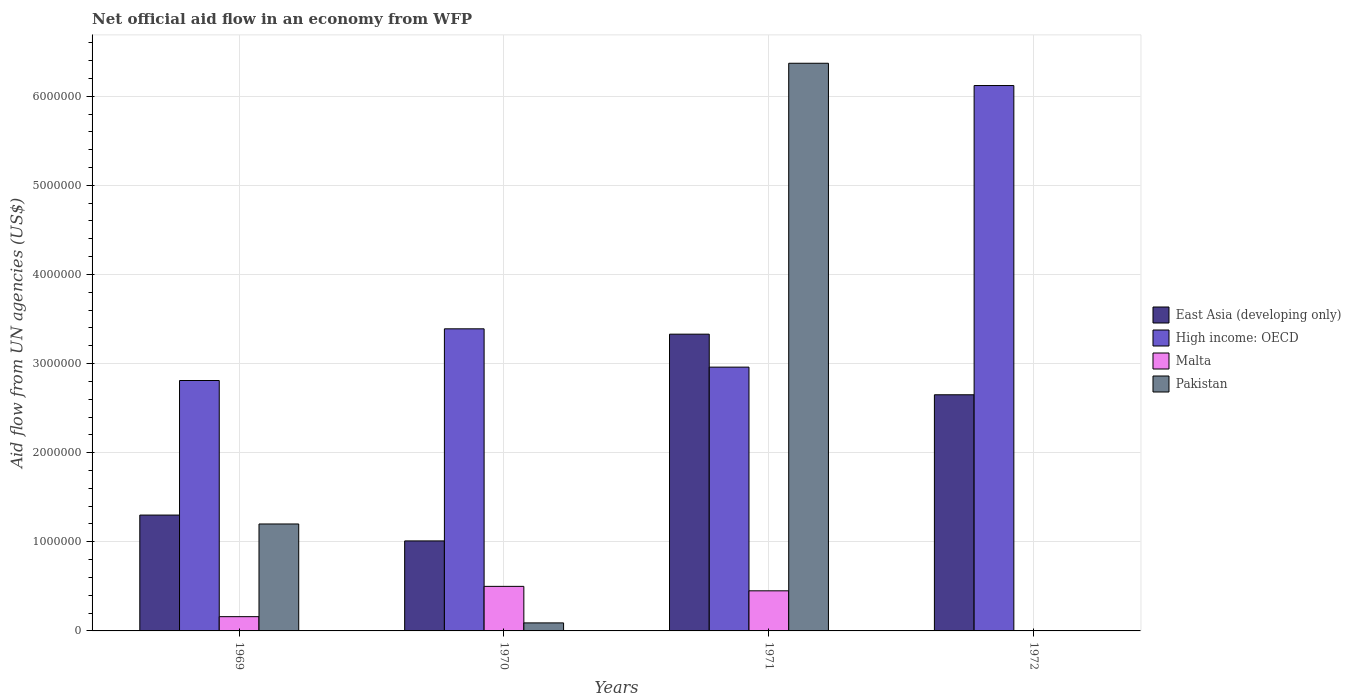How many groups of bars are there?
Provide a short and direct response. 4. Are the number of bars per tick equal to the number of legend labels?
Your answer should be very brief. No. How many bars are there on the 3rd tick from the right?
Provide a succinct answer. 4. What is the label of the 3rd group of bars from the left?
Give a very brief answer. 1971. What is the net official aid flow in Pakistan in 1971?
Offer a terse response. 6.37e+06. Across all years, what is the maximum net official aid flow in High income: OECD?
Ensure brevity in your answer.  6.12e+06. In which year was the net official aid flow in High income: OECD maximum?
Ensure brevity in your answer.  1972. What is the total net official aid flow in High income: OECD in the graph?
Your response must be concise. 1.53e+07. What is the difference between the net official aid flow in East Asia (developing only) in 1969 and that in 1972?
Your answer should be very brief. -1.35e+06. What is the average net official aid flow in East Asia (developing only) per year?
Ensure brevity in your answer.  2.07e+06. In the year 1972, what is the difference between the net official aid flow in High income: OECD and net official aid flow in East Asia (developing only)?
Provide a short and direct response. 3.47e+06. What is the ratio of the net official aid flow in High income: OECD in 1970 to that in 1971?
Keep it short and to the point. 1.15. Is the difference between the net official aid flow in High income: OECD in 1971 and 1972 greater than the difference between the net official aid flow in East Asia (developing only) in 1971 and 1972?
Provide a succinct answer. No. What is the difference between the highest and the second highest net official aid flow in High income: OECD?
Provide a succinct answer. 2.73e+06. What is the difference between the highest and the lowest net official aid flow in High income: OECD?
Keep it short and to the point. 3.31e+06. In how many years, is the net official aid flow in Malta greater than the average net official aid flow in Malta taken over all years?
Make the answer very short. 2. Is it the case that in every year, the sum of the net official aid flow in Pakistan and net official aid flow in Malta is greater than the net official aid flow in East Asia (developing only)?
Your answer should be compact. No. How many bars are there?
Offer a very short reply. 14. Are all the bars in the graph horizontal?
Give a very brief answer. No. How many years are there in the graph?
Provide a short and direct response. 4. Where does the legend appear in the graph?
Provide a succinct answer. Center right. How many legend labels are there?
Ensure brevity in your answer.  4. What is the title of the graph?
Ensure brevity in your answer.  Net official aid flow in an economy from WFP. What is the label or title of the X-axis?
Your response must be concise. Years. What is the label or title of the Y-axis?
Your answer should be very brief. Aid flow from UN agencies (US$). What is the Aid flow from UN agencies (US$) in East Asia (developing only) in 1969?
Give a very brief answer. 1.30e+06. What is the Aid flow from UN agencies (US$) of High income: OECD in 1969?
Your answer should be compact. 2.81e+06. What is the Aid flow from UN agencies (US$) of Malta in 1969?
Make the answer very short. 1.60e+05. What is the Aid flow from UN agencies (US$) in Pakistan in 1969?
Give a very brief answer. 1.20e+06. What is the Aid flow from UN agencies (US$) in East Asia (developing only) in 1970?
Give a very brief answer. 1.01e+06. What is the Aid flow from UN agencies (US$) in High income: OECD in 1970?
Offer a terse response. 3.39e+06. What is the Aid flow from UN agencies (US$) in Malta in 1970?
Give a very brief answer. 5.00e+05. What is the Aid flow from UN agencies (US$) of Pakistan in 1970?
Provide a short and direct response. 9.00e+04. What is the Aid flow from UN agencies (US$) of East Asia (developing only) in 1971?
Give a very brief answer. 3.33e+06. What is the Aid flow from UN agencies (US$) in High income: OECD in 1971?
Make the answer very short. 2.96e+06. What is the Aid flow from UN agencies (US$) of Malta in 1971?
Ensure brevity in your answer.  4.50e+05. What is the Aid flow from UN agencies (US$) in Pakistan in 1971?
Keep it short and to the point. 6.37e+06. What is the Aid flow from UN agencies (US$) in East Asia (developing only) in 1972?
Ensure brevity in your answer.  2.65e+06. What is the Aid flow from UN agencies (US$) of High income: OECD in 1972?
Offer a terse response. 6.12e+06. What is the Aid flow from UN agencies (US$) in Malta in 1972?
Your response must be concise. 0. What is the Aid flow from UN agencies (US$) in Pakistan in 1972?
Make the answer very short. 0. Across all years, what is the maximum Aid flow from UN agencies (US$) of East Asia (developing only)?
Offer a terse response. 3.33e+06. Across all years, what is the maximum Aid flow from UN agencies (US$) in High income: OECD?
Keep it short and to the point. 6.12e+06. Across all years, what is the maximum Aid flow from UN agencies (US$) of Malta?
Make the answer very short. 5.00e+05. Across all years, what is the maximum Aid flow from UN agencies (US$) in Pakistan?
Provide a succinct answer. 6.37e+06. Across all years, what is the minimum Aid flow from UN agencies (US$) in East Asia (developing only)?
Provide a succinct answer. 1.01e+06. Across all years, what is the minimum Aid flow from UN agencies (US$) of High income: OECD?
Keep it short and to the point. 2.81e+06. Across all years, what is the minimum Aid flow from UN agencies (US$) in Pakistan?
Give a very brief answer. 0. What is the total Aid flow from UN agencies (US$) in East Asia (developing only) in the graph?
Offer a terse response. 8.29e+06. What is the total Aid flow from UN agencies (US$) in High income: OECD in the graph?
Keep it short and to the point. 1.53e+07. What is the total Aid flow from UN agencies (US$) in Malta in the graph?
Offer a very short reply. 1.11e+06. What is the total Aid flow from UN agencies (US$) of Pakistan in the graph?
Your answer should be compact. 7.66e+06. What is the difference between the Aid flow from UN agencies (US$) of East Asia (developing only) in 1969 and that in 1970?
Your answer should be very brief. 2.90e+05. What is the difference between the Aid flow from UN agencies (US$) in High income: OECD in 1969 and that in 1970?
Offer a very short reply. -5.80e+05. What is the difference between the Aid flow from UN agencies (US$) of Malta in 1969 and that in 1970?
Your answer should be compact. -3.40e+05. What is the difference between the Aid flow from UN agencies (US$) of Pakistan in 1969 and that in 1970?
Provide a succinct answer. 1.11e+06. What is the difference between the Aid flow from UN agencies (US$) of East Asia (developing only) in 1969 and that in 1971?
Provide a short and direct response. -2.03e+06. What is the difference between the Aid flow from UN agencies (US$) of Pakistan in 1969 and that in 1971?
Your answer should be very brief. -5.17e+06. What is the difference between the Aid flow from UN agencies (US$) in East Asia (developing only) in 1969 and that in 1972?
Keep it short and to the point. -1.35e+06. What is the difference between the Aid flow from UN agencies (US$) of High income: OECD in 1969 and that in 1972?
Make the answer very short. -3.31e+06. What is the difference between the Aid flow from UN agencies (US$) of East Asia (developing only) in 1970 and that in 1971?
Offer a terse response. -2.32e+06. What is the difference between the Aid flow from UN agencies (US$) in High income: OECD in 1970 and that in 1971?
Your answer should be compact. 4.30e+05. What is the difference between the Aid flow from UN agencies (US$) in Pakistan in 1970 and that in 1971?
Offer a terse response. -6.28e+06. What is the difference between the Aid flow from UN agencies (US$) in East Asia (developing only) in 1970 and that in 1972?
Provide a succinct answer. -1.64e+06. What is the difference between the Aid flow from UN agencies (US$) in High income: OECD in 1970 and that in 1972?
Offer a very short reply. -2.73e+06. What is the difference between the Aid flow from UN agencies (US$) in East Asia (developing only) in 1971 and that in 1972?
Provide a short and direct response. 6.80e+05. What is the difference between the Aid flow from UN agencies (US$) of High income: OECD in 1971 and that in 1972?
Your answer should be very brief. -3.16e+06. What is the difference between the Aid flow from UN agencies (US$) of East Asia (developing only) in 1969 and the Aid flow from UN agencies (US$) of High income: OECD in 1970?
Your answer should be compact. -2.09e+06. What is the difference between the Aid flow from UN agencies (US$) of East Asia (developing only) in 1969 and the Aid flow from UN agencies (US$) of Pakistan in 1970?
Keep it short and to the point. 1.21e+06. What is the difference between the Aid flow from UN agencies (US$) of High income: OECD in 1969 and the Aid flow from UN agencies (US$) of Malta in 1970?
Make the answer very short. 2.31e+06. What is the difference between the Aid flow from UN agencies (US$) in High income: OECD in 1969 and the Aid flow from UN agencies (US$) in Pakistan in 1970?
Keep it short and to the point. 2.72e+06. What is the difference between the Aid flow from UN agencies (US$) of East Asia (developing only) in 1969 and the Aid flow from UN agencies (US$) of High income: OECD in 1971?
Your answer should be compact. -1.66e+06. What is the difference between the Aid flow from UN agencies (US$) of East Asia (developing only) in 1969 and the Aid flow from UN agencies (US$) of Malta in 1971?
Keep it short and to the point. 8.50e+05. What is the difference between the Aid flow from UN agencies (US$) of East Asia (developing only) in 1969 and the Aid flow from UN agencies (US$) of Pakistan in 1971?
Give a very brief answer. -5.07e+06. What is the difference between the Aid flow from UN agencies (US$) of High income: OECD in 1969 and the Aid flow from UN agencies (US$) of Malta in 1971?
Your response must be concise. 2.36e+06. What is the difference between the Aid flow from UN agencies (US$) of High income: OECD in 1969 and the Aid flow from UN agencies (US$) of Pakistan in 1971?
Give a very brief answer. -3.56e+06. What is the difference between the Aid flow from UN agencies (US$) in Malta in 1969 and the Aid flow from UN agencies (US$) in Pakistan in 1971?
Ensure brevity in your answer.  -6.21e+06. What is the difference between the Aid flow from UN agencies (US$) of East Asia (developing only) in 1969 and the Aid flow from UN agencies (US$) of High income: OECD in 1972?
Your answer should be very brief. -4.82e+06. What is the difference between the Aid flow from UN agencies (US$) of East Asia (developing only) in 1970 and the Aid flow from UN agencies (US$) of High income: OECD in 1971?
Your response must be concise. -1.95e+06. What is the difference between the Aid flow from UN agencies (US$) in East Asia (developing only) in 1970 and the Aid flow from UN agencies (US$) in Malta in 1971?
Provide a short and direct response. 5.60e+05. What is the difference between the Aid flow from UN agencies (US$) in East Asia (developing only) in 1970 and the Aid flow from UN agencies (US$) in Pakistan in 1971?
Give a very brief answer. -5.36e+06. What is the difference between the Aid flow from UN agencies (US$) of High income: OECD in 1970 and the Aid flow from UN agencies (US$) of Malta in 1971?
Your answer should be compact. 2.94e+06. What is the difference between the Aid flow from UN agencies (US$) in High income: OECD in 1970 and the Aid flow from UN agencies (US$) in Pakistan in 1971?
Give a very brief answer. -2.98e+06. What is the difference between the Aid flow from UN agencies (US$) of Malta in 1970 and the Aid flow from UN agencies (US$) of Pakistan in 1971?
Make the answer very short. -5.87e+06. What is the difference between the Aid flow from UN agencies (US$) in East Asia (developing only) in 1970 and the Aid flow from UN agencies (US$) in High income: OECD in 1972?
Your answer should be very brief. -5.11e+06. What is the difference between the Aid flow from UN agencies (US$) in East Asia (developing only) in 1971 and the Aid flow from UN agencies (US$) in High income: OECD in 1972?
Your answer should be very brief. -2.79e+06. What is the average Aid flow from UN agencies (US$) in East Asia (developing only) per year?
Make the answer very short. 2.07e+06. What is the average Aid flow from UN agencies (US$) in High income: OECD per year?
Offer a terse response. 3.82e+06. What is the average Aid flow from UN agencies (US$) in Malta per year?
Your response must be concise. 2.78e+05. What is the average Aid flow from UN agencies (US$) in Pakistan per year?
Give a very brief answer. 1.92e+06. In the year 1969, what is the difference between the Aid flow from UN agencies (US$) of East Asia (developing only) and Aid flow from UN agencies (US$) of High income: OECD?
Your answer should be very brief. -1.51e+06. In the year 1969, what is the difference between the Aid flow from UN agencies (US$) in East Asia (developing only) and Aid flow from UN agencies (US$) in Malta?
Offer a terse response. 1.14e+06. In the year 1969, what is the difference between the Aid flow from UN agencies (US$) in High income: OECD and Aid flow from UN agencies (US$) in Malta?
Your response must be concise. 2.65e+06. In the year 1969, what is the difference between the Aid flow from UN agencies (US$) in High income: OECD and Aid flow from UN agencies (US$) in Pakistan?
Keep it short and to the point. 1.61e+06. In the year 1969, what is the difference between the Aid flow from UN agencies (US$) in Malta and Aid flow from UN agencies (US$) in Pakistan?
Make the answer very short. -1.04e+06. In the year 1970, what is the difference between the Aid flow from UN agencies (US$) in East Asia (developing only) and Aid flow from UN agencies (US$) in High income: OECD?
Provide a succinct answer. -2.38e+06. In the year 1970, what is the difference between the Aid flow from UN agencies (US$) in East Asia (developing only) and Aid flow from UN agencies (US$) in Malta?
Keep it short and to the point. 5.10e+05. In the year 1970, what is the difference between the Aid flow from UN agencies (US$) of East Asia (developing only) and Aid flow from UN agencies (US$) of Pakistan?
Your response must be concise. 9.20e+05. In the year 1970, what is the difference between the Aid flow from UN agencies (US$) in High income: OECD and Aid flow from UN agencies (US$) in Malta?
Make the answer very short. 2.89e+06. In the year 1970, what is the difference between the Aid flow from UN agencies (US$) in High income: OECD and Aid flow from UN agencies (US$) in Pakistan?
Your response must be concise. 3.30e+06. In the year 1970, what is the difference between the Aid flow from UN agencies (US$) in Malta and Aid flow from UN agencies (US$) in Pakistan?
Keep it short and to the point. 4.10e+05. In the year 1971, what is the difference between the Aid flow from UN agencies (US$) of East Asia (developing only) and Aid flow from UN agencies (US$) of High income: OECD?
Your answer should be compact. 3.70e+05. In the year 1971, what is the difference between the Aid flow from UN agencies (US$) in East Asia (developing only) and Aid flow from UN agencies (US$) in Malta?
Make the answer very short. 2.88e+06. In the year 1971, what is the difference between the Aid flow from UN agencies (US$) of East Asia (developing only) and Aid flow from UN agencies (US$) of Pakistan?
Ensure brevity in your answer.  -3.04e+06. In the year 1971, what is the difference between the Aid flow from UN agencies (US$) of High income: OECD and Aid flow from UN agencies (US$) of Malta?
Your answer should be compact. 2.51e+06. In the year 1971, what is the difference between the Aid flow from UN agencies (US$) in High income: OECD and Aid flow from UN agencies (US$) in Pakistan?
Provide a short and direct response. -3.41e+06. In the year 1971, what is the difference between the Aid flow from UN agencies (US$) in Malta and Aid flow from UN agencies (US$) in Pakistan?
Provide a succinct answer. -5.92e+06. In the year 1972, what is the difference between the Aid flow from UN agencies (US$) in East Asia (developing only) and Aid flow from UN agencies (US$) in High income: OECD?
Your response must be concise. -3.47e+06. What is the ratio of the Aid flow from UN agencies (US$) of East Asia (developing only) in 1969 to that in 1970?
Offer a very short reply. 1.29. What is the ratio of the Aid flow from UN agencies (US$) in High income: OECD in 1969 to that in 1970?
Offer a very short reply. 0.83. What is the ratio of the Aid flow from UN agencies (US$) in Malta in 1969 to that in 1970?
Ensure brevity in your answer.  0.32. What is the ratio of the Aid flow from UN agencies (US$) in Pakistan in 1969 to that in 1970?
Your response must be concise. 13.33. What is the ratio of the Aid flow from UN agencies (US$) of East Asia (developing only) in 1969 to that in 1971?
Offer a very short reply. 0.39. What is the ratio of the Aid flow from UN agencies (US$) in High income: OECD in 1969 to that in 1971?
Your answer should be very brief. 0.95. What is the ratio of the Aid flow from UN agencies (US$) of Malta in 1969 to that in 1971?
Your answer should be very brief. 0.36. What is the ratio of the Aid flow from UN agencies (US$) of Pakistan in 1969 to that in 1971?
Your answer should be very brief. 0.19. What is the ratio of the Aid flow from UN agencies (US$) of East Asia (developing only) in 1969 to that in 1972?
Provide a succinct answer. 0.49. What is the ratio of the Aid flow from UN agencies (US$) of High income: OECD in 1969 to that in 1972?
Ensure brevity in your answer.  0.46. What is the ratio of the Aid flow from UN agencies (US$) in East Asia (developing only) in 1970 to that in 1971?
Your response must be concise. 0.3. What is the ratio of the Aid flow from UN agencies (US$) of High income: OECD in 1970 to that in 1971?
Your response must be concise. 1.15. What is the ratio of the Aid flow from UN agencies (US$) in Pakistan in 1970 to that in 1971?
Make the answer very short. 0.01. What is the ratio of the Aid flow from UN agencies (US$) of East Asia (developing only) in 1970 to that in 1972?
Provide a short and direct response. 0.38. What is the ratio of the Aid flow from UN agencies (US$) in High income: OECD in 1970 to that in 1972?
Your response must be concise. 0.55. What is the ratio of the Aid flow from UN agencies (US$) in East Asia (developing only) in 1971 to that in 1972?
Keep it short and to the point. 1.26. What is the ratio of the Aid flow from UN agencies (US$) of High income: OECD in 1971 to that in 1972?
Provide a short and direct response. 0.48. What is the difference between the highest and the second highest Aid flow from UN agencies (US$) of East Asia (developing only)?
Give a very brief answer. 6.80e+05. What is the difference between the highest and the second highest Aid flow from UN agencies (US$) of High income: OECD?
Provide a short and direct response. 2.73e+06. What is the difference between the highest and the second highest Aid flow from UN agencies (US$) of Malta?
Offer a terse response. 5.00e+04. What is the difference between the highest and the second highest Aid flow from UN agencies (US$) of Pakistan?
Ensure brevity in your answer.  5.17e+06. What is the difference between the highest and the lowest Aid flow from UN agencies (US$) in East Asia (developing only)?
Provide a short and direct response. 2.32e+06. What is the difference between the highest and the lowest Aid flow from UN agencies (US$) in High income: OECD?
Provide a succinct answer. 3.31e+06. What is the difference between the highest and the lowest Aid flow from UN agencies (US$) of Malta?
Give a very brief answer. 5.00e+05. What is the difference between the highest and the lowest Aid flow from UN agencies (US$) in Pakistan?
Ensure brevity in your answer.  6.37e+06. 